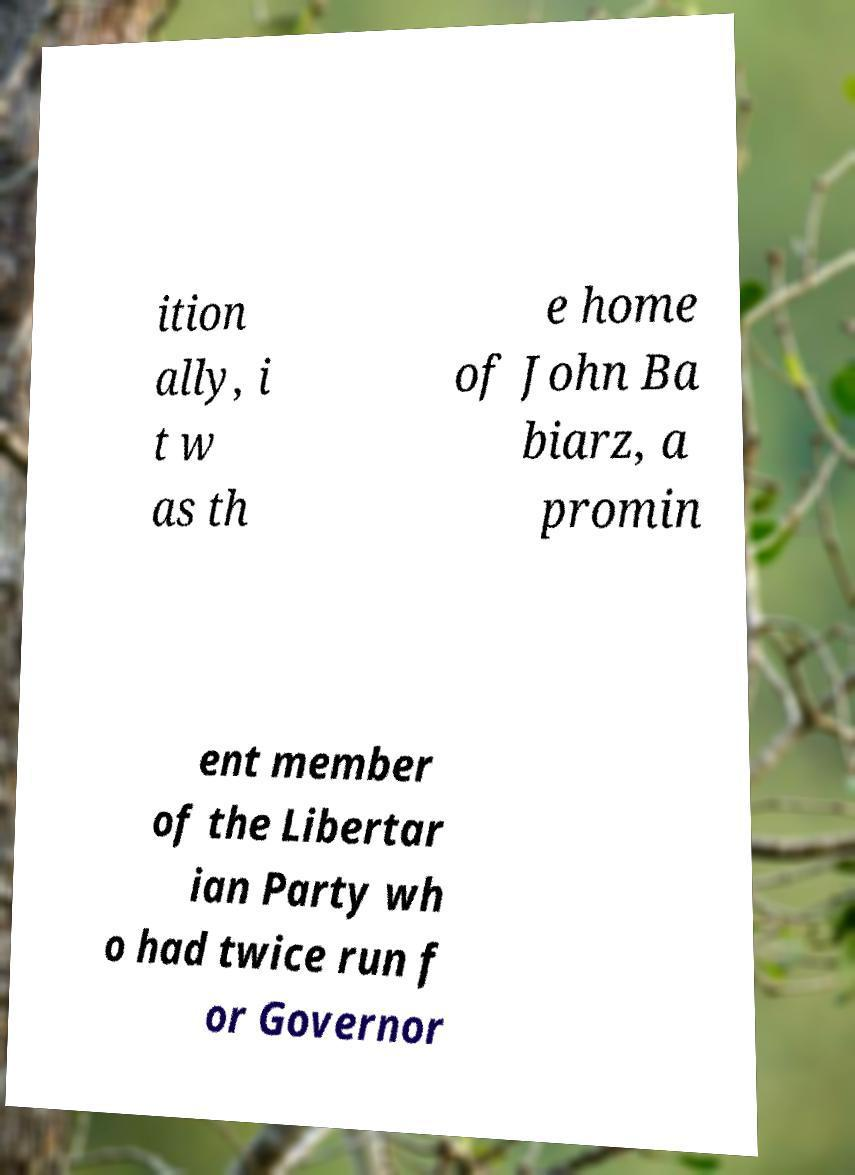Could you extract and type out the text from this image? ition ally, i t w as th e home of John Ba biarz, a promin ent member of the Libertar ian Party wh o had twice run f or Governor 